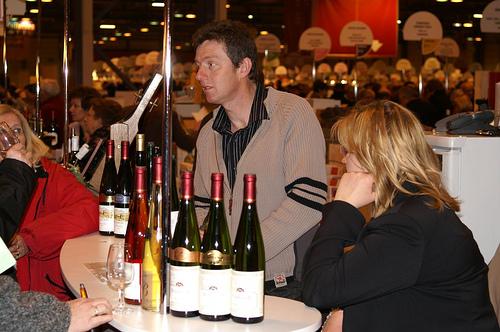How many wine bottles are on the table?
Be succinct. 8. How many male are there in this picture?
Write a very short answer. 1. Are they drinking the wine?
Answer briefly. Yes. 